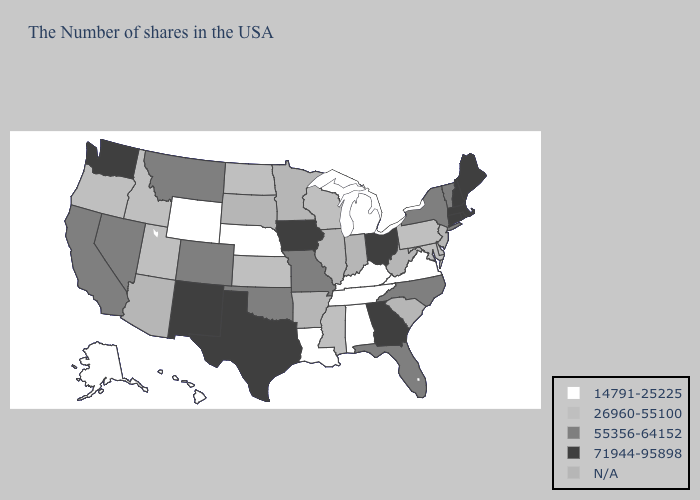How many symbols are there in the legend?
Be succinct. 5. Name the states that have a value in the range 71944-95898?
Be succinct. Maine, Massachusetts, Rhode Island, New Hampshire, Connecticut, Ohio, Georgia, Iowa, Texas, New Mexico, Washington. Which states have the highest value in the USA?
Answer briefly. Maine, Massachusetts, Rhode Island, New Hampshire, Connecticut, Ohio, Georgia, Iowa, Texas, New Mexico, Washington. Does the first symbol in the legend represent the smallest category?
Write a very short answer. Yes. What is the highest value in states that border California?
Answer briefly. 55356-64152. Among the states that border Missouri , which have the highest value?
Write a very short answer. Iowa. Name the states that have a value in the range N/A?
Concise answer only. New Jersey, South Carolina, West Virginia, Indiana, Illinois, Arkansas, Minnesota, South Dakota, Arizona. Name the states that have a value in the range 71944-95898?
Keep it brief. Maine, Massachusetts, Rhode Island, New Hampshire, Connecticut, Ohio, Georgia, Iowa, Texas, New Mexico, Washington. Which states have the lowest value in the Northeast?
Short answer required. Pennsylvania. Does the first symbol in the legend represent the smallest category?
Write a very short answer. Yes. Which states hav the highest value in the MidWest?
Short answer required. Ohio, Iowa. What is the highest value in states that border New Mexico?
Keep it brief. 71944-95898. Which states have the lowest value in the South?
Quick response, please. Virginia, Kentucky, Alabama, Tennessee, Louisiana. Among the states that border Virginia , which have the lowest value?
Answer briefly. Kentucky, Tennessee. Does the first symbol in the legend represent the smallest category?
Concise answer only. Yes. 